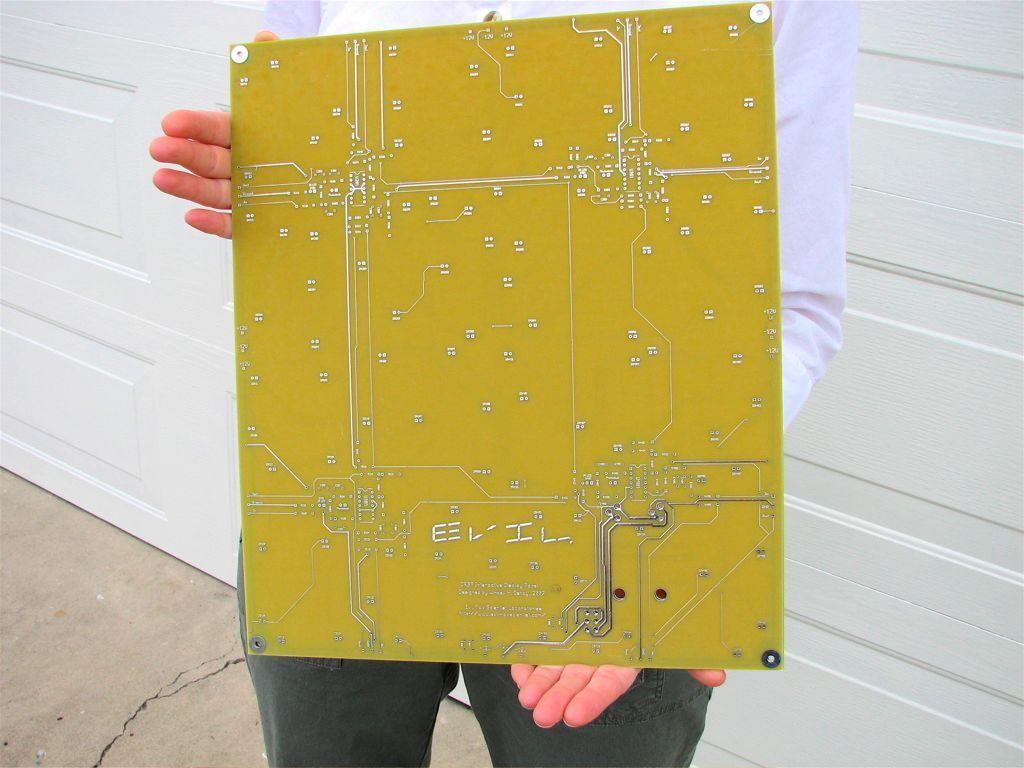How would you summarize this image in a sentence or two? There is one person standing and wearing a white color shirt is holding a circuit board in the middle of this image, and there is a white color wooden wall in the background. 